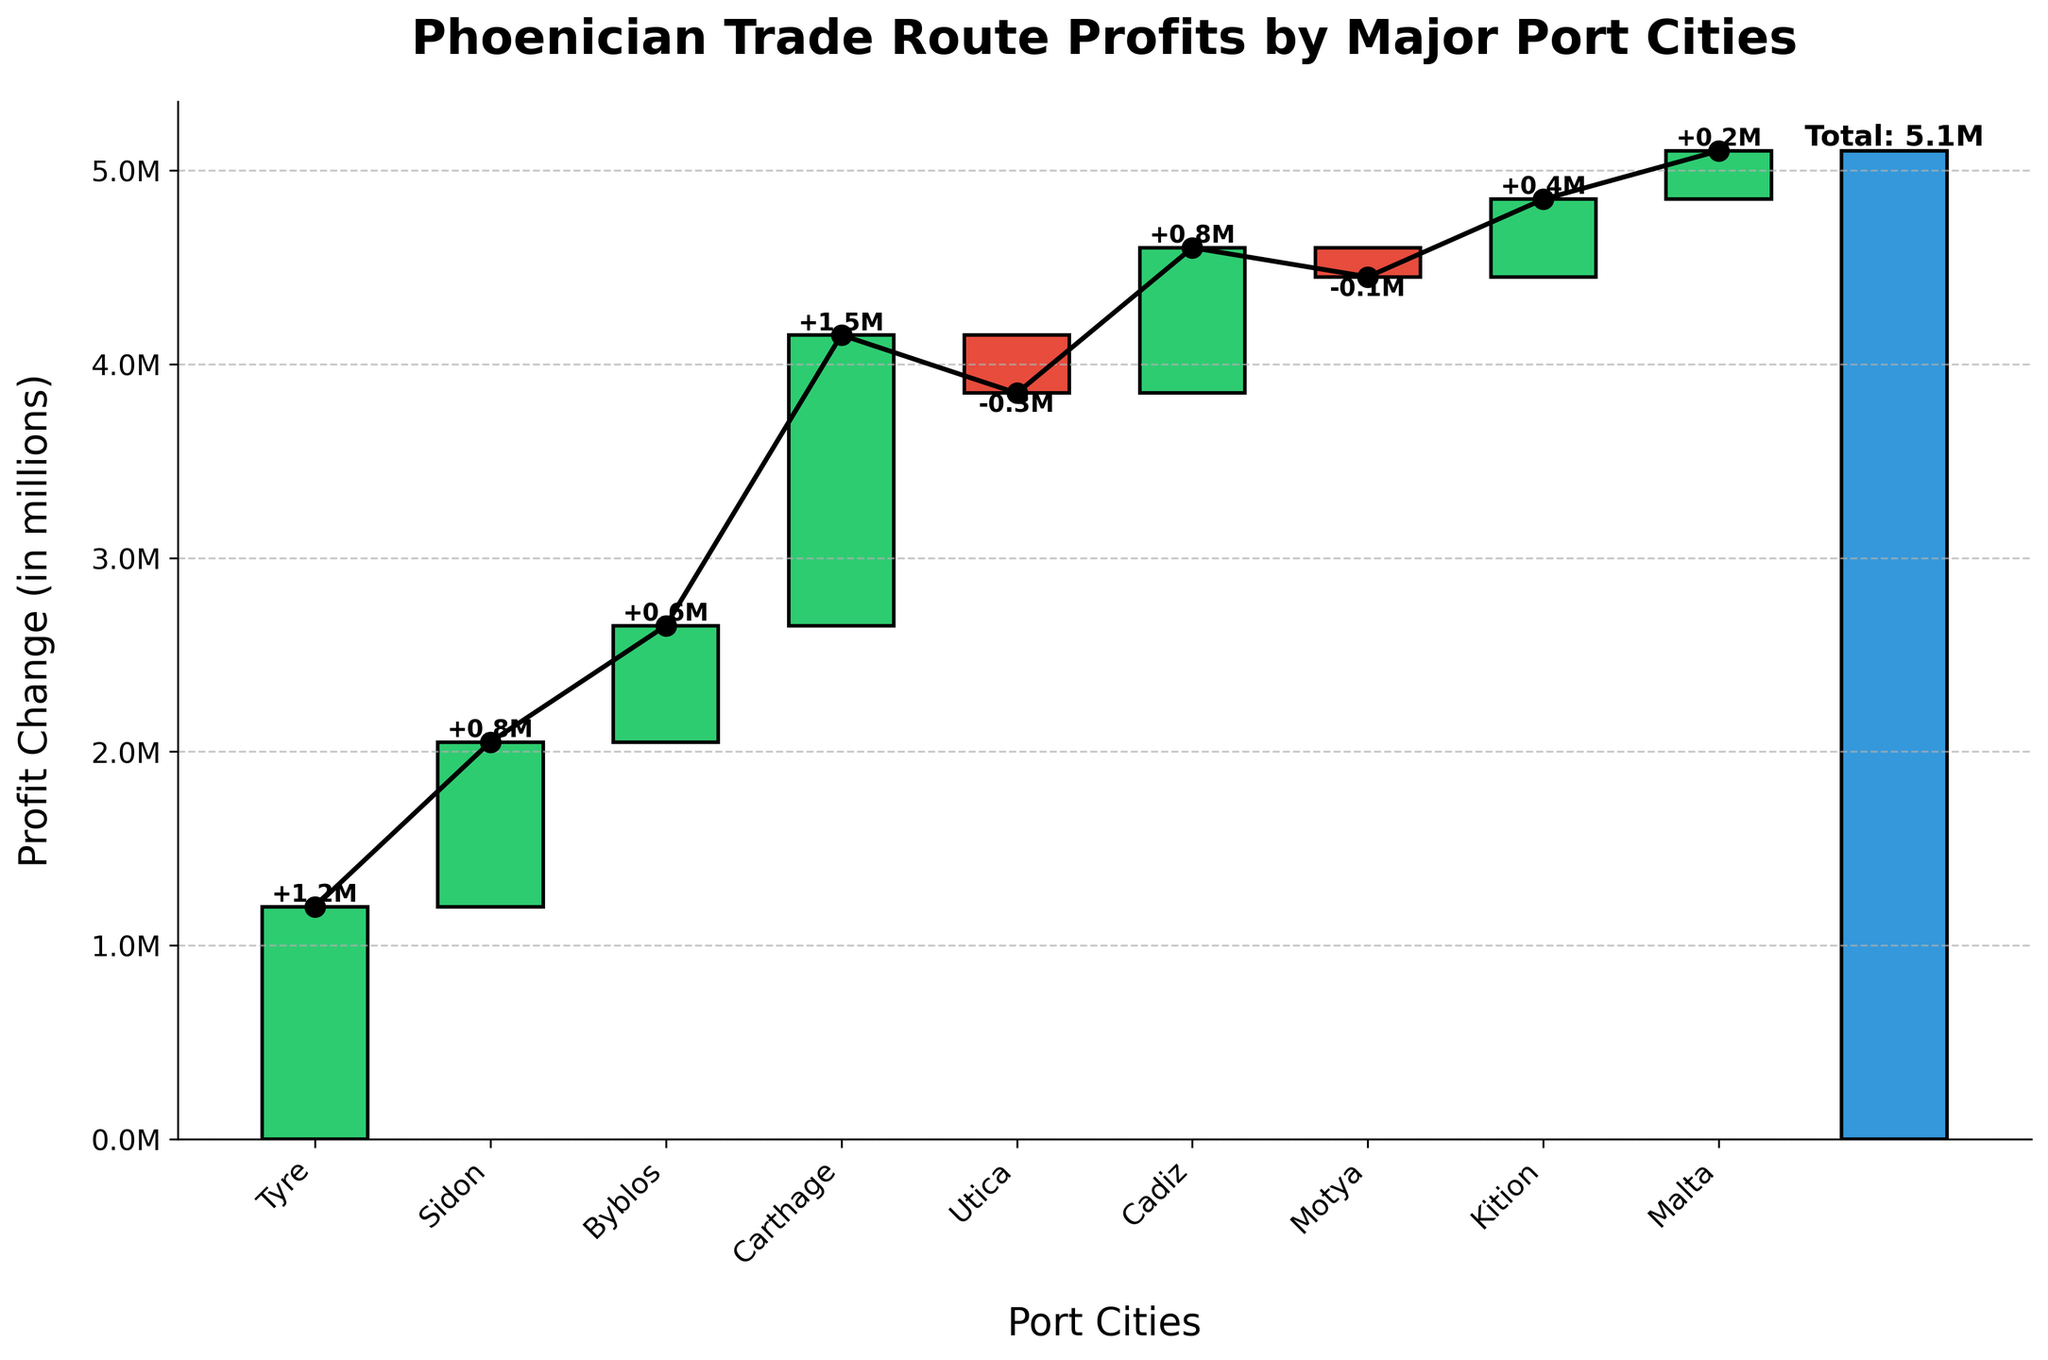How many port cities show a negative profit change? We need to count the bars that fall below the baseline in the chart. According to the chart, Utica and Motya show a negative profit change.
Answer: 2 What is the total profit change for all port cities? The bar labeled 'Total' represents the total profit change. According to the chart, this total is 5.1M.
Answer: 5.1M Which port city has the highest profit change? By comparing the heights of the bars, Carthage has the highest bar among all, indicating it has the highest profit change of 1.5M.
Answer: Carthage What is the cumulative profit change after Byblos? Sum the profit changes for the cities up to Byblos: 1.2M (Tyre) + 0.85M (Sidon) + 0.6M (Byblos) = 2.65M.
Answer: 2.65M Which port city marks the first decrease in profit in the chart? Following the sequence of bars, Utica is the first port city where the bar drops below the baseline.
Answer: Utica If we remove the negative profits from Utica and Motya, what would be the total profit? First, sum the total profit excluding the negative values of Utica and Motya: 5.1M (Total) - 0.3M (Utica) - 0.15M (Motya) = 4.65M.
Answer: 4.65M How much does Kition contribute to the total profit change? The height of the bar for Kition indicates its profit change, which is 0.4M.
Answer: 0.4M Which port city has the lowest positive profit change? By comparing the heights of the positive bars, Malta has the lowest positive profit change with 0.25M.
Answer: Malta What's the difference in profit change between Carthage and Tyre? Subtract the profit change of Tyre from Carthage: 1.5M (Carthage) - 1.2M (Tyre) = 0.3M.
Answer: 0.3M What is the cumulative profit change after Sidon but before including Carthage? Sum the profit changes up to Sidon and before adding Carthage: 1.2M (Tyre) + 0.85M (Sidon) = 2.05M.
Answer: 2.05M 